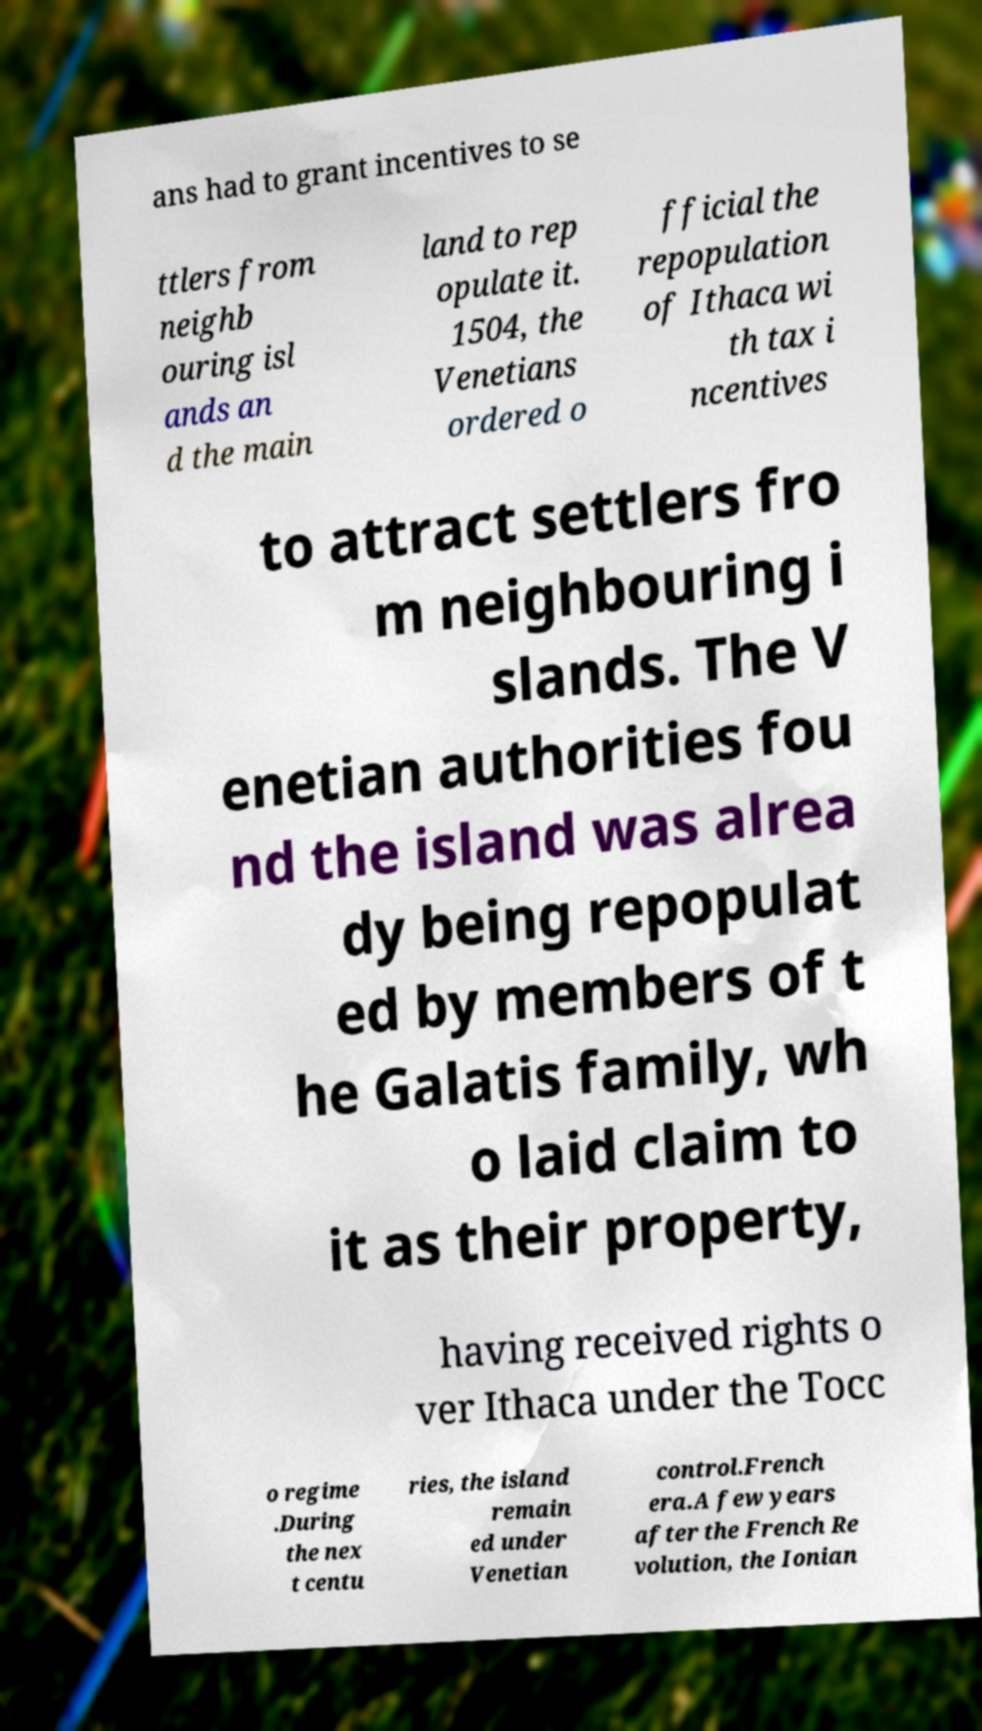For documentation purposes, I need the text within this image transcribed. Could you provide that? ans had to grant incentives to se ttlers from neighb ouring isl ands an d the main land to rep opulate it. 1504, the Venetians ordered o fficial the repopulation of Ithaca wi th tax i ncentives to attract settlers fro m neighbouring i slands. The V enetian authorities fou nd the island was alrea dy being repopulat ed by members of t he Galatis family, wh o laid claim to it as their property, having received rights o ver Ithaca under the Tocc o regime .During the nex t centu ries, the island remain ed under Venetian control.French era.A few years after the French Re volution, the Ionian 